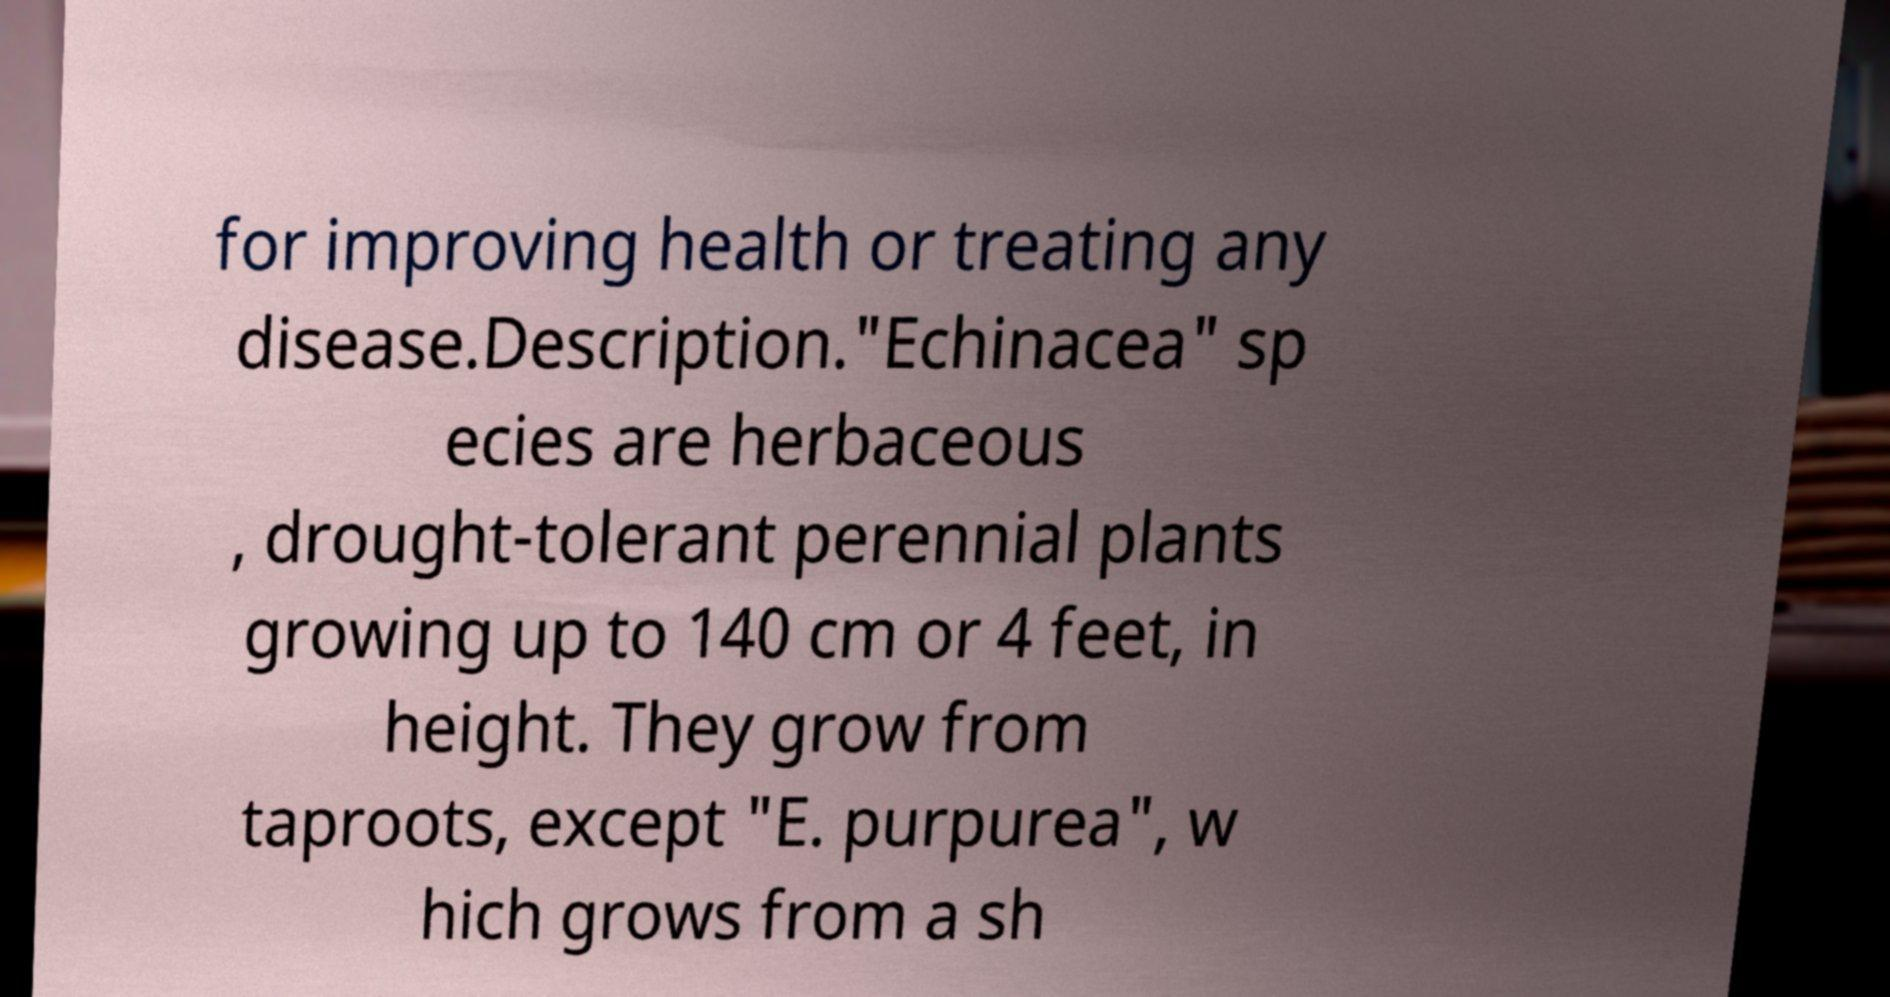Please read and relay the text visible in this image. What does it say? for improving health or treating any disease.Description."Echinacea" sp ecies are herbaceous , drought-tolerant perennial plants growing up to 140 cm or 4 feet, in height. They grow from taproots, except "E. purpurea", w hich grows from a sh 